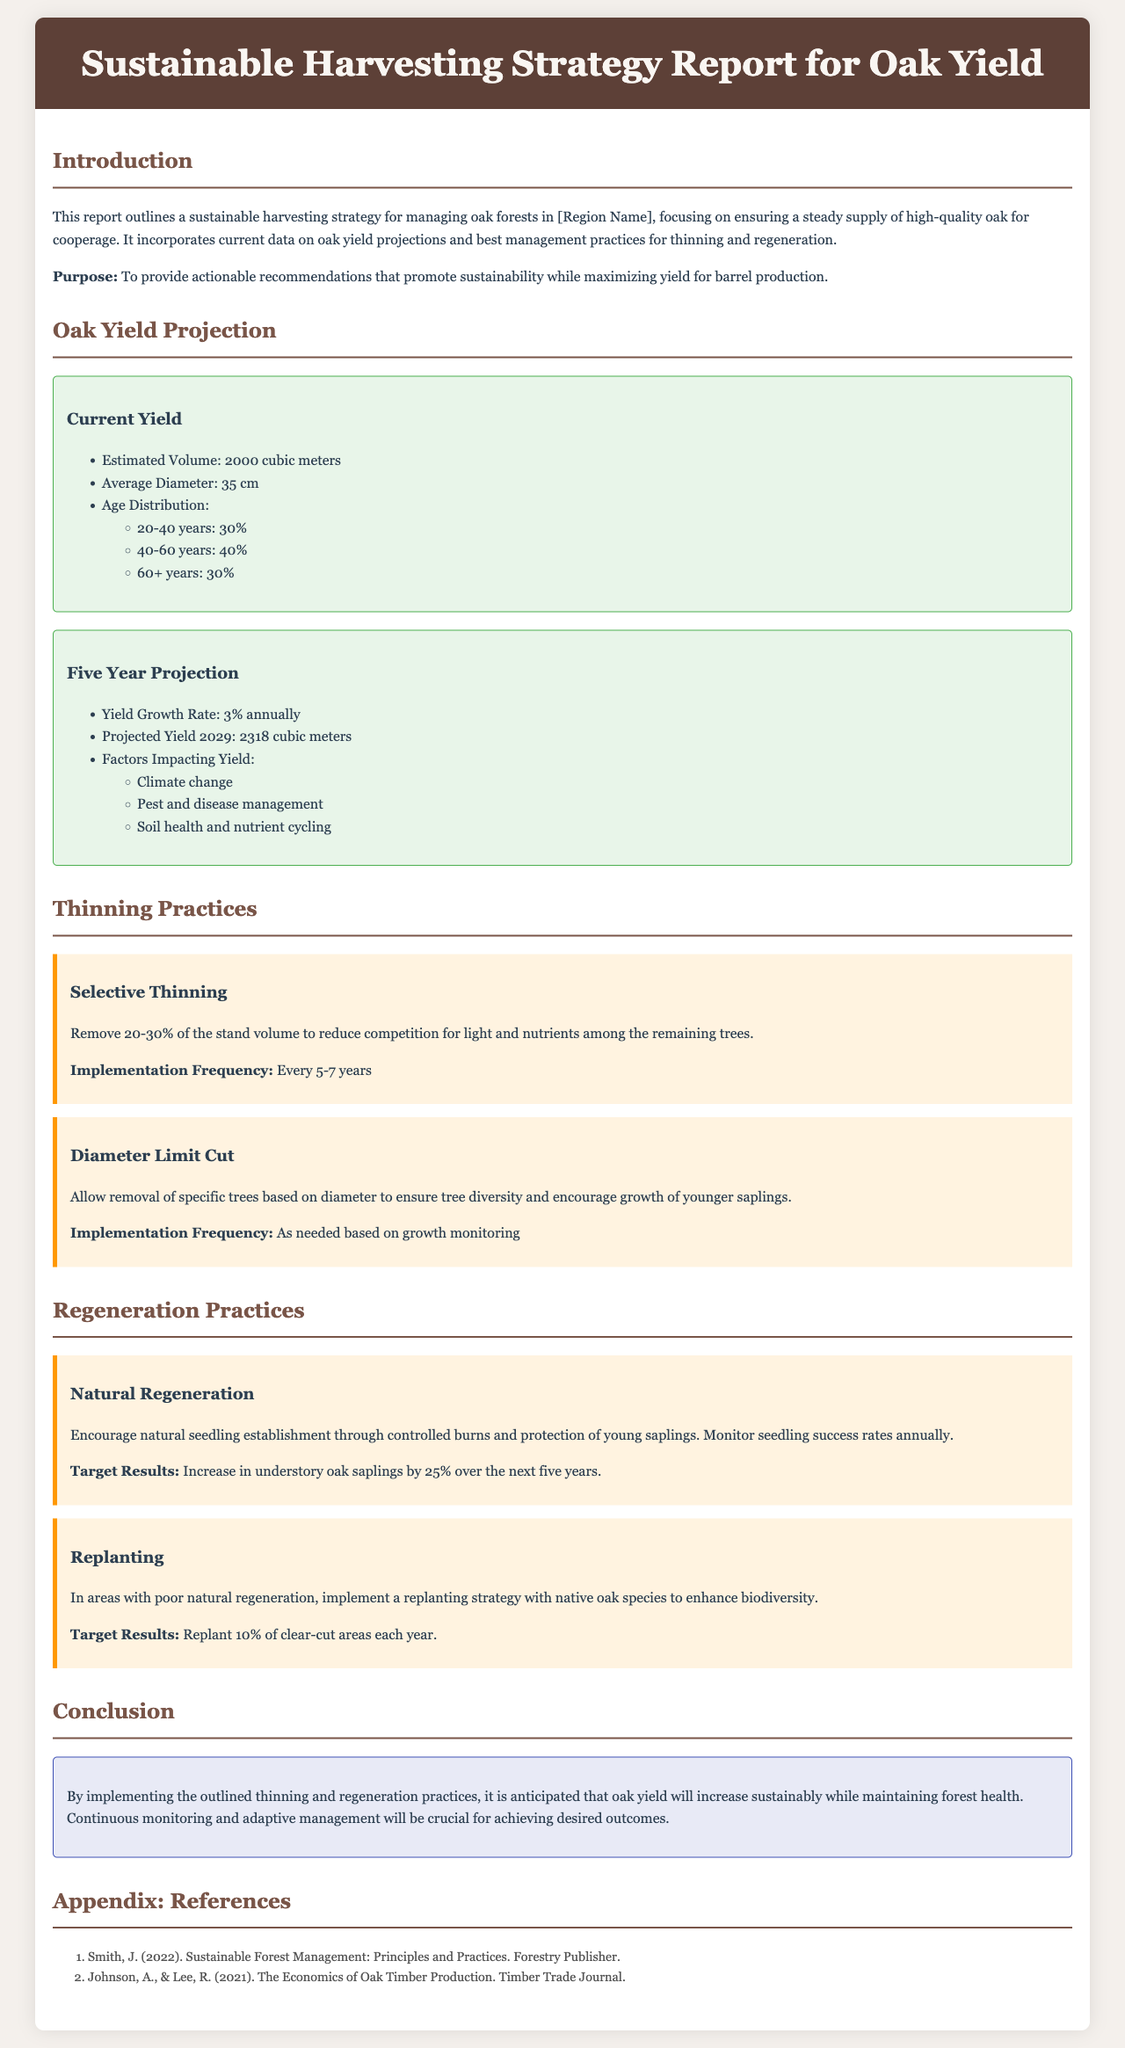what is the estimated current volume of oak? The estimated current volume of oak is listed under Current Yield section as 2000 cubic meters.
Answer: 2000 cubic meters what is the projected yield for 2029? The projected yield for 2029 is mentioned in the Five Year Projection section as 2318 cubic meters.
Answer: 2318 cubic meters what percentage of oak trees are aged 40-60 years? The age distribution states that 40% of the oak trees are aged 40-60 years.
Answer: 40% what is the recommended frequency for selective thinning implementation? The recommendation for selective thinning indicates that it should be implemented every 5-7 years.
Answer: Every 5-7 years what is a target result for natural regeneration practices? The target result for natural regeneration is stated as an increase in understory oak saplings by 25% over the next five years.
Answer: Increase by 25% which factor influencing yield is related to climate? Climate change is identified as a factor impacting yield in the Five Year Projection section.
Answer: Climate change what is a recommended action for areas with poor natural regeneration? The report recommends implementing a replanting strategy in areas with poor natural regeneration.
Answer: Replanting strategy what type of trees should be encouraged for replanting? The document specifies that native oak species should be used for replanting.
Answer: Native oak species 